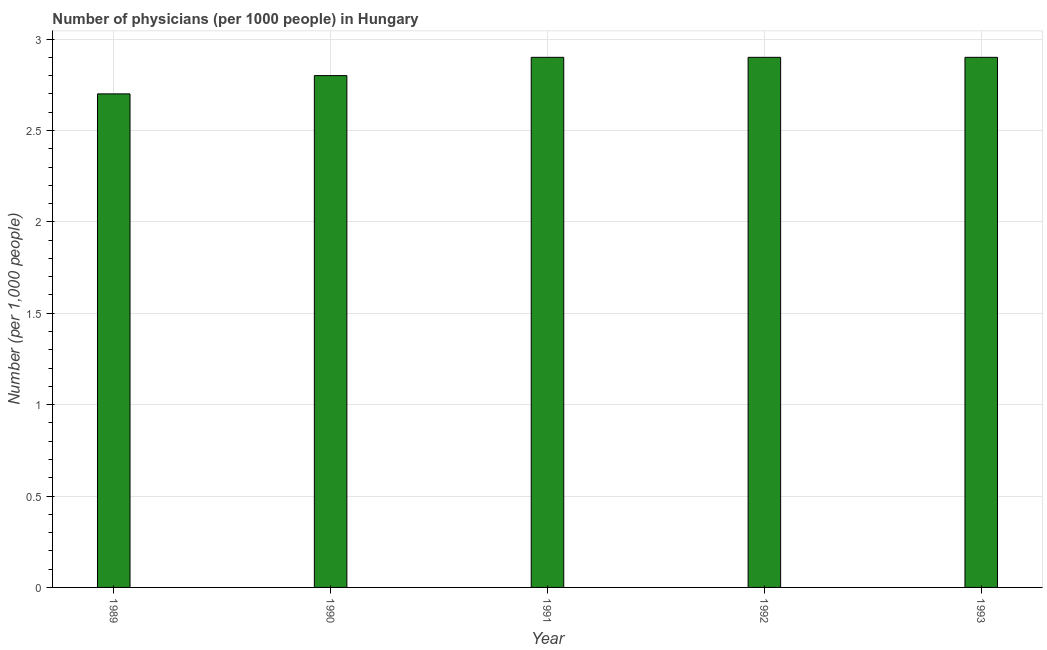Does the graph contain grids?
Keep it short and to the point. Yes. What is the title of the graph?
Keep it short and to the point. Number of physicians (per 1000 people) in Hungary. What is the label or title of the X-axis?
Make the answer very short. Year. What is the label or title of the Y-axis?
Provide a short and direct response. Number (per 1,0 people). What is the number of physicians in 1989?
Keep it short and to the point. 2.7. Across all years, what is the minimum number of physicians?
Offer a terse response. 2.7. In which year was the number of physicians minimum?
Your answer should be compact. 1989. What is the sum of the number of physicians?
Make the answer very short. 14.2. What is the difference between the number of physicians in 1990 and 1991?
Offer a very short reply. -0.1. What is the average number of physicians per year?
Offer a very short reply. 2.84. What is the median number of physicians?
Provide a short and direct response. 2.9. In how many years, is the number of physicians greater than 0.7 ?
Make the answer very short. 5. Do a majority of the years between 1992 and 1989 (inclusive) have number of physicians greater than 2.6 ?
Your answer should be very brief. Yes. What is the ratio of the number of physicians in 1989 to that in 1993?
Your answer should be compact. 0.93. What is the difference between the highest and the second highest number of physicians?
Provide a succinct answer. 0. Is the sum of the number of physicians in 1989 and 1991 greater than the maximum number of physicians across all years?
Keep it short and to the point. Yes. What is the difference between the highest and the lowest number of physicians?
Your answer should be compact. 0.2. Are all the bars in the graph horizontal?
Your response must be concise. No. How many years are there in the graph?
Keep it short and to the point. 5. What is the difference between two consecutive major ticks on the Y-axis?
Offer a terse response. 0.5. Are the values on the major ticks of Y-axis written in scientific E-notation?
Ensure brevity in your answer.  No. What is the Number (per 1,000 people) of 1989?
Provide a succinct answer. 2.7. What is the Number (per 1,000 people) in 1992?
Keep it short and to the point. 2.9. What is the difference between the Number (per 1,000 people) in 1989 and 1991?
Make the answer very short. -0.2. What is the difference between the Number (per 1,000 people) in 1989 and 1992?
Provide a succinct answer. -0.2. What is the difference between the Number (per 1,000 people) in 1990 and 1991?
Your answer should be very brief. -0.1. What is the difference between the Number (per 1,000 people) in 1990 and 1992?
Offer a terse response. -0.1. What is the difference between the Number (per 1,000 people) in 1990 and 1993?
Make the answer very short. -0.1. What is the difference between the Number (per 1,000 people) in 1991 and 1993?
Offer a terse response. 0. What is the ratio of the Number (per 1,000 people) in 1989 to that in 1990?
Your answer should be compact. 0.96. What is the ratio of the Number (per 1,000 people) in 1989 to that in 1991?
Ensure brevity in your answer.  0.93. What is the ratio of the Number (per 1,000 people) in 1989 to that in 1992?
Your answer should be compact. 0.93. What is the ratio of the Number (per 1,000 people) in 1990 to that in 1992?
Offer a terse response. 0.97. What is the ratio of the Number (per 1,000 people) in 1990 to that in 1993?
Offer a very short reply. 0.97. What is the ratio of the Number (per 1,000 people) in 1992 to that in 1993?
Offer a terse response. 1. 